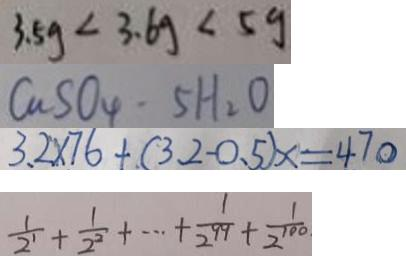<formula> <loc_0><loc_0><loc_500><loc_500>3 . 5 g < 3 . 6 g < 5 g 
 C a S O _ { 4 } \cdot 5 H _ { 2 } O 
 3 . 2 \times 7 6 + ( 3 . 2 - 0 . 5 ) x = 4 7 0 
 \frac { 1 } { 2 ^ { 1 } } + \frac { 1 } { 2 ^ { 2 } } + \cdots + \frac { 1 } { 2 ^ { 9 9 } } + \frac { 1 } { 2 ^ { 1 0 0 } }</formula> 